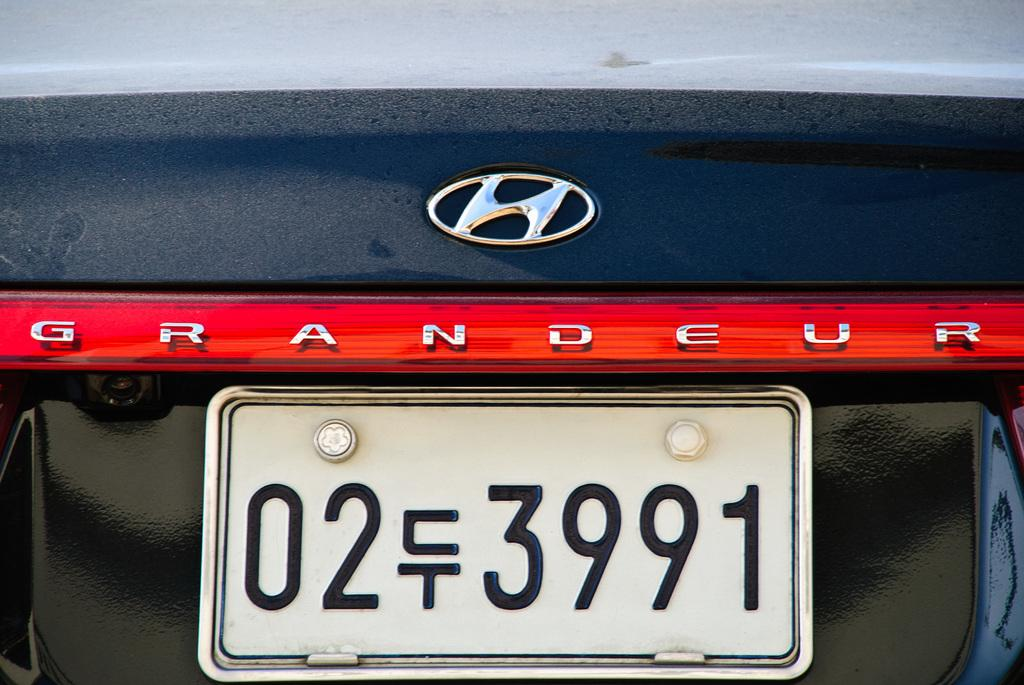<image>
Give a short and clear explanation of the subsequent image. The back of a Hyundai Grandeur with a license plate. 